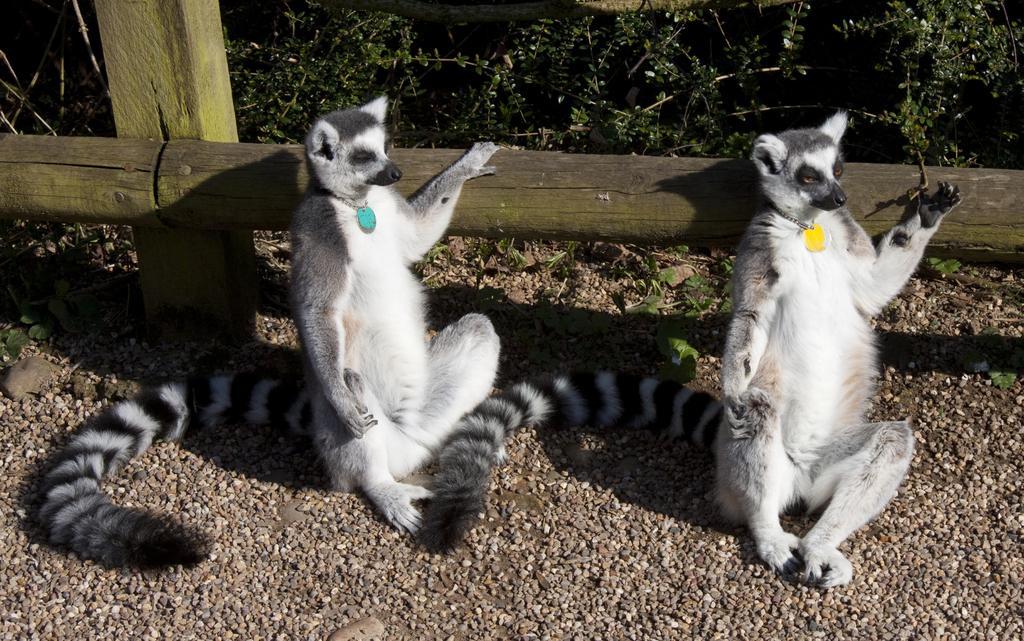Could you give a brief overview of what you see in this image? In this image I can see two animal which are white, black and grey in color are sitting on the ground. I can see badges which are yellow and blue in color in their necks. I can see a wooden log and few trees behind them. 